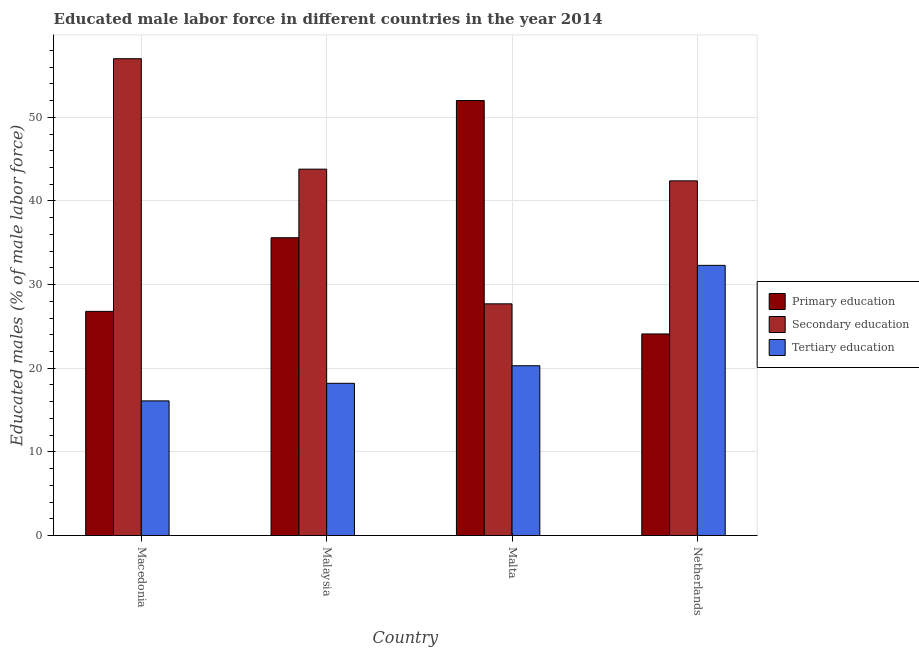How many different coloured bars are there?
Your answer should be compact. 3. Are the number of bars on each tick of the X-axis equal?
Your answer should be very brief. Yes. What is the label of the 4th group of bars from the left?
Give a very brief answer. Netherlands. What is the percentage of male labor force who received secondary education in Netherlands?
Offer a terse response. 42.4. Across all countries, what is the minimum percentage of male labor force who received primary education?
Keep it short and to the point. 24.1. In which country was the percentage of male labor force who received secondary education maximum?
Make the answer very short. Macedonia. In which country was the percentage of male labor force who received secondary education minimum?
Your answer should be very brief. Malta. What is the total percentage of male labor force who received secondary education in the graph?
Your answer should be compact. 170.9. What is the difference between the percentage of male labor force who received primary education in Malaysia and that in Netherlands?
Provide a short and direct response. 11.5. What is the difference between the percentage of male labor force who received tertiary education in Malaysia and the percentage of male labor force who received secondary education in Macedonia?
Provide a succinct answer. -38.8. What is the average percentage of male labor force who received primary education per country?
Provide a succinct answer. 34.62. What is the difference between the percentage of male labor force who received tertiary education and percentage of male labor force who received secondary education in Malta?
Offer a very short reply. -7.4. What is the ratio of the percentage of male labor force who received primary education in Macedonia to that in Malaysia?
Give a very brief answer. 0.75. Is the percentage of male labor force who received tertiary education in Malaysia less than that in Malta?
Your answer should be compact. Yes. What is the difference between the highest and the second highest percentage of male labor force who received secondary education?
Offer a very short reply. 13.2. What is the difference between the highest and the lowest percentage of male labor force who received tertiary education?
Ensure brevity in your answer.  16.2. In how many countries, is the percentage of male labor force who received tertiary education greater than the average percentage of male labor force who received tertiary education taken over all countries?
Offer a terse response. 1. What does the 3rd bar from the left in Macedonia represents?
Offer a terse response. Tertiary education. What does the 2nd bar from the right in Netherlands represents?
Offer a very short reply. Secondary education. Is it the case that in every country, the sum of the percentage of male labor force who received primary education and percentage of male labor force who received secondary education is greater than the percentage of male labor force who received tertiary education?
Offer a terse response. Yes. How many bars are there?
Provide a succinct answer. 12. Are all the bars in the graph horizontal?
Give a very brief answer. No. How many countries are there in the graph?
Your answer should be compact. 4. Does the graph contain any zero values?
Keep it short and to the point. No. Does the graph contain grids?
Provide a short and direct response. Yes. Where does the legend appear in the graph?
Your answer should be compact. Center right. What is the title of the graph?
Give a very brief answer. Educated male labor force in different countries in the year 2014. What is the label or title of the X-axis?
Provide a succinct answer. Country. What is the label or title of the Y-axis?
Keep it short and to the point. Educated males (% of male labor force). What is the Educated males (% of male labor force) of Primary education in Macedonia?
Give a very brief answer. 26.8. What is the Educated males (% of male labor force) in Tertiary education in Macedonia?
Offer a terse response. 16.1. What is the Educated males (% of male labor force) of Primary education in Malaysia?
Provide a succinct answer. 35.6. What is the Educated males (% of male labor force) in Secondary education in Malaysia?
Provide a succinct answer. 43.8. What is the Educated males (% of male labor force) of Tertiary education in Malaysia?
Give a very brief answer. 18.2. What is the Educated males (% of male labor force) of Primary education in Malta?
Ensure brevity in your answer.  52. What is the Educated males (% of male labor force) in Secondary education in Malta?
Provide a succinct answer. 27.7. What is the Educated males (% of male labor force) in Tertiary education in Malta?
Your answer should be compact. 20.3. What is the Educated males (% of male labor force) in Primary education in Netherlands?
Your response must be concise. 24.1. What is the Educated males (% of male labor force) of Secondary education in Netherlands?
Make the answer very short. 42.4. What is the Educated males (% of male labor force) in Tertiary education in Netherlands?
Make the answer very short. 32.3. Across all countries, what is the maximum Educated males (% of male labor force) of Secondary education?
Give a very brief answer. 57. Across all countries, what is the maximum Educated males (% of male labor force) of Tertiary education?
Ensure brevity in your answer.  32.3. Across all countries, what is the minimum Educated males (% of male labor force) of Primary education?
Your answer should be compact. 24.1. Across all countries, what is the minimum Educated males (% of male labor force) in Secondary education?
Offer a terse response. 27.7. Across all countries, what is the minimum Educated males (% of male labor force) in Tertiary education?
Give a very brief answer. 16.1. What is the total Educated males (% of male labor force) in Primary education in the graph?
Make the answer very short. 138.5. What is the total Educated males (% of male labor force) of Secondary education in the graph?
Offer a very short reply. 170.9. What is the total Educated males (% of male labor force) in Tertiary education in the graph?
Keep it short and to the point. 86.9. What is the difference between the Educated males (% of male labor force) in Primary education in Macedonia and that in Malaysia?
Keep it short and to the point. -8.8. What is the difference between the Educated males (% of male labor force) of Tertiary education in Macedonia and that in Malaysia?
Make the answer very short. -2.1. What is the difference between the Educated males (% of male labor force) in Primary education in Macedonia and that in Malta?
Keep it short and to the point. -25.2. What is the difference between the Educated males (% of male labor force) of Secondary education in Macedonia and that in Malta?
Offer a terse response. 29.3. What is the difference between the Educated males (% of male labor force) in Tertiary education in Macedonia and that in Malta?
Offer a very short reply. -4.2. What is the difference between the Educated males (% of male labor force) in Secondary education in Macedonia and that in Netherlands?
Your answer should be compact. 14.6. What is the difference between the Educated males (% of male labor force) of Tertiary education in Macedonia and that in Netherlands?
Ensure brevity in your answer.  -16.2. What is the difference between the Educated males (% of male labor force) of Primary education in Malaysia and that in Malta?
Offer a terse response. -16.4. What is the difference between the Educated males (% of male labor force) in Secondary education in Malaysia and that in Netherlands?
Make the answer very short. 1.4. What is the difference between the Educated males (% of male labor force) in Tertiary education in Malaysia and that in Netherlands?
Make the answer very short. -14.1. What is the difference between the Educated males (% of male labor force) in Primary education in Malta and that in Netherlands?
Offer a terse response. 27.9. What is the difference between the Educated males (% of male labor force) of Secondary education in Malta and that in Netherlands?
Provide a succinct answer. -14.7. What is the difference between the Educated males (% of male labor force) in Primary education in Macedonia and the Educated males (% of male labor force) in Tertiary education in Malaysia?
Provide a short and direct response. 8.6. What is the difference between the Educated males (% of male labor force) of Secondary education in Macedonia and the Educated males (% of male labor force) of Tertiary education in Malaysia?
Provide a succinct answer. 38.8. What is the difference between the Educated males (% of male labor force) of Primary education in Macedonia and the Educated males (% of male labor force) of Tertiary education in Malta?
Your answer should be very brief. 6.5. What is the difference between the Educated males (% of male labor force) in Secondary education in Macedonia and the Educated males (% of male labor force) in Tertiary education in Malta?
Give a very brief answer. 36.7. What is the difference between the Educated males (% of male labor force) of Primary education in Macedonia and the Educated males (% of male labor force) of Secondary education in Netherlands?
Offer a terse response. -15.6. What is the difference between the Educated males (% of male labor force) in Secondary education in Macedonia and the Educated males (% of male labor force) in Tertiary education in Netherlands?
Provide a short and direct response. 24.7. What is the difference between the Educated males (% of male labor force) in Primary education in Malaysia and the Educated males (% of male labor force) in Secondary education in Malta?
Your answer should be compact. 7.9. What is the difference between the Educated males (% of male labor force) in Secondary education in Malaysia and the Educated males (% of male labor force) in Tertiary education in Malta?
Keep it short and to the point. 23.5. What is the difference between the Educated males (% of male labor force) in Primary education in Malaysia and the Educated males (% of male labor force) in Tertiary education in Netherlands?
Give a very brief answer. 3.3. What is the difference between the Educated males (% of male labor force) of Secondary education in Malaysia and the Educated males (% of male labor force) of Tertiary education in Netherlands?
Your response must be concise. 11.5. What is the difference between the Educated males (% of male labor force) of Primary education in Malta and the Educated males (% of male labor force) of Secondary education in Netherlands?
Keep it short and to the point. 9.6. What is the difference between the Educated males (% of male labor force) of Secondary education in Malta and the Educated males (% of male labor force) of Tertiary education in Netherlands?
Give a very brief answer. -4.6. What is the average Educated males (% of male labor force) of Primary education per country?
Provide a succinct answer. 34.62. What is the average Educated males (% of male labor force) in Secondary education per country?
Keep it short and to the point. 42.73. What is the average Educated males (% of male labor force) of Tertiary education per country?
Offer a terse response. 21.73. What is the difference between the Educated males (% of male labor force) in Primary education and Educated males (% of male labor force) in Secondary education in Macedonia?
Provide a succinct answer. -30.2. What is the difference between the Educated males (% of male labor force) in Primary education and Educated males (% of male labor force) in Tertiary education in Macedonia?
Provide a succinct answer. 10.7. What is the difference between the Educated males (% of male labor force) in Secondary education and Educated males (% of male labor force) in Tertiary education in Macedonia?
Your answer should be compact. 40.9. What is the difference between the Educated males (% of male labor force) of Primary education and Educated males (% of male labor force) of Secondary education in Malaysia?
Your answer should be very brief. -8.2. What is the difference between the Educated males (% of male labor force) in Secondary education and Educated males (% of male labor force) in Tertiary education in Malaysia?
Your response must be concise. 25.6. What is the difference between the Educated males (% of male labor force) of Primary education and Educated males (% of male labor force) of Secondary education in Malta?
Your answer should be compact. 24.3. What is the difference between the Educated males (% of male labor force) in Primary education and Educated males (% of male labor force) in Tertiary education in Malta?
Your answer should be compact. 31.7. What is the difference between the Educated males (% of male labor force) in Secondary education and Educated males (% of male labor force) in Tertiary education in Malta?
Offer a terse response. 7.4. What is the difference between the Educated males (% of male labor force) of Primary education and Educated males (% of male labor force) of Secondary education in Netherlands?
Keep it short and to the point. -18.3. What is the difference between the Educated males (% of male labor force) of Primary education and Educated males (% of male labor force) of Tertiary education in Netherlands?
Provide a succinct answer. -8.2. What is the difference between the Educated males (% of male labor force) in Secondary education and Educated males (% of male labor force) in Tertiary education in Netherlands?
Make the answer very short. 10.1. What is the ratio of the Educated males (% of male labor force) in Primary education in Macedonia to that in Malaysia?
Give a very brief answer. 0.75. What is the ratio of the Educated males (% of male labor force) of Secondary education in Macedonia to that in Malaysia?
Your answer should be very brief. 1.3. What is the ratio of the Educated males (% of male labor force) of Tertiary education in Macedonia to that in Malaysia?
Keep it short and to the point. 0.88. What is the ratio of the Educated males (% of male labor force) of Primary education in Macedonia to that in Malta?
Your response must be concise. 0.52. What is the ratio of the Educated males (% of male labor force) of Secondary education in Macedonia to that in Malta?
Your answer should be very brief. 2.06. What is the ratio of the Educated males (% of male labor force) of Tertiary education in Macedonia to that in Malta?
Ensure brevity in your answer.  0.79. What is the ratio of the Educated males (% of male labor force) in Primary education in Macedonia to that in Netherlands?
Your response must be concise. 1.11. What is the ratio of the Educated males (% of male labor force) in Secondary education in Macedonia to that in Netherlands?
Keep it short and to the point. 1.34. What is the ratio of the Educated males (% of male labor force) of Tertiary education in Macedonia to that in Netherlands?
Ensure brevity in your answer.  0.5. What is the ratio of the Educated males (% of male labor force) in Primary education in Malaysia to that in Malta?
Offer a very short reply. 0.68. What is the ratio of the Educated males (% of male labor force) of Secondary education in Malaysia to that in Malta?
Keep it short and to the point. 1.58. What is the ratio of the Educated males (% of male labor force) in Tertiary education in Malaysia to that in Malta?
Provide a short and direct response. 0.9. What is the ratio of the Educated males (% of male labor force) of Primary education in Malaysia to that in Netherlands?
Your answer should be very brief. 1.48. What is the ratio of the Educated males (% of male labor force) of Secondary education in Malaysia to that in Netherlands?
Give a very brief answer. 1.03. What is the ratio of the Educated males (% of male labor force) in Tertiary education in Malaysia to that in Netherlands?
Make the answer very short. 0.56. What is the ratio of the Educated males (% of male labor force) of Primary education in Malta to that in Netherlands?
Provide a short and direct response. 2.16. What is the ratio of the Educated males (% of male labor force) in Secondary education in Malta to that in Netherlands?
Keep it short and to the point. 0.65. What is the ratio of the Educated males (% of male labor force) of Tertiary education in Malta to that in Netherlands?
Offer a very short reply. 0.63. What is the difference between the highest and the second highest Educated males (% of male labor force) in Tertiary education?
Give a very brief answer. 12. What is the difference between the highest and the lowest Educated males (% of male labor force) of Primary education?
Provide a short and direct response. 27.9. What is the difference between the highest and the lowest Educated males (% of male labor force) of Secondary education?
Keep it short and to the point. 29.3. What is the difference between the highest and the lowest Educated males (% of male labor force) in Tertiary education?
Make the answer very short. 16.2. 